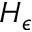<formula> <loc_0><loc_0><loc_500><loc_500>H _ { \epsilon }</formula> 